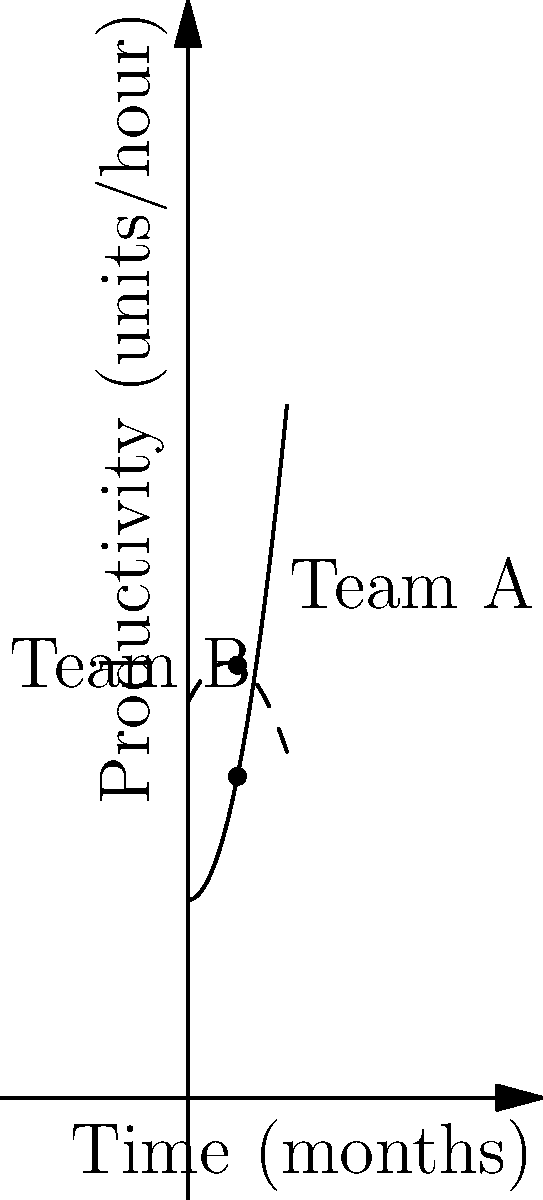The line graph shows the productivity trends of two teams (A and B) over a 10-month period. At which month does Team B's productivity surpass Team A's, and what strategic decision should be considered based on this information? To answer this question, we need to analyze the graph and interpret its implications for employee performance management:

1. Observe the trends:
   - Team A (solid line) shows a steadily increasing productivity trend.
   - Team B (dashed line) starts higher but shows a curved trend that eventually decreases.

2. Find the intersection point:
   - The two lines cross at approximately the 5-month mark.
   - This intersection indicates the point where Team B's productivity surpasses Team A's.

3. Interpret the data:
   - Before the 5-month mark, Team B was more productive.
   - After the 5-month mark, Team A becomes more productive and continues to improve.

4. Strategic considerations:
   - Team A's consistent improvement suggests effective long-term strategies or training.
   - Team B's declining productivity after the peak indicates potential issues that need addressing.

5. Recommended decision:
   - Investigate the factors contributing to Team A's continuous improvement.
   - Assess what's causing Team B's productivity decline and implement corrective measures.
   - Consider applying Team A's successful strategies to Team B.
   - Monitor both teams closely to ensure overall organizational productivity is optimized.
Answer: Month 5; Investigate Team A's success factors and address Team B's decline. 